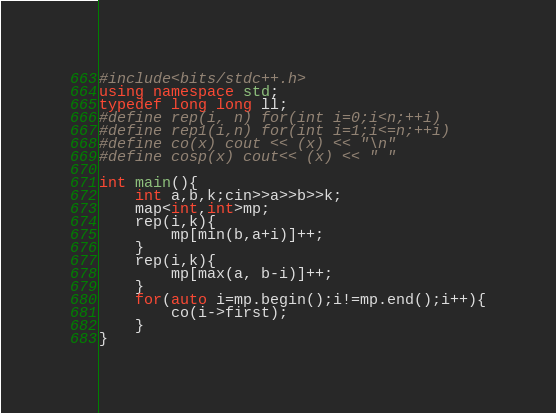Convert code to text. <code><loc_0><loc_0><loc_500><loc_500><_C++_>#include<bits/stdc++.h>
using namespace std;
typedef long long ll;
#define rep(i, n) for(int i=0;i<n;++i)
#define rep1(i,n) for(int i=1;i<=n;++i)
#define co(x) cout << (x) << "\n"
#define cosp(x) cout<< (x) << " "

int main(){
    int a,b,k;cin>>a>>b>>k;
    map<int,int>mp;
    rep(i,k){
        mp[min(b,a+i)]++;
    }
    rep(i,k){
        mp[max(a, b-i)]++;
    }
    for(auto i=mp.begin();i!=mp.end();i++){
        co(i->first);
    }
}</code> 